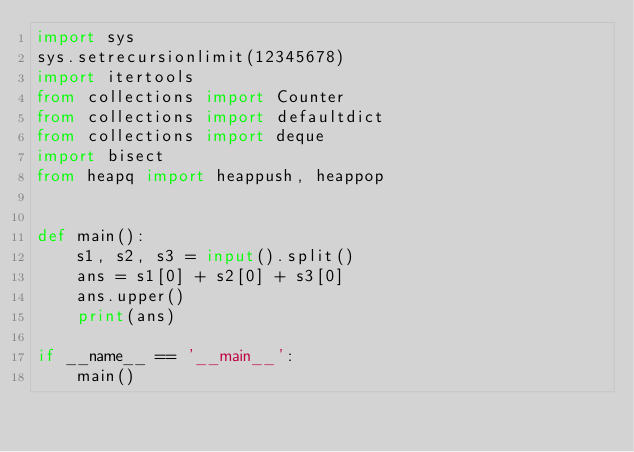<code> <loc_0><loc_0><loc_500><loc_500><_Python_>import sys
sys.setrecursionlimit(12345678)
import itertools
from collections import Counter
from collections import defaultdict
from collections import deque
import bisect
from heapq import heappush, heappop


def main():
    s1, s2, s3 = input().split()
    ans = s1[0] + s2[0] + s3[0]
    ans.upper()
    print(ans)

if __name__ == '__main__':
    main()

</code> 